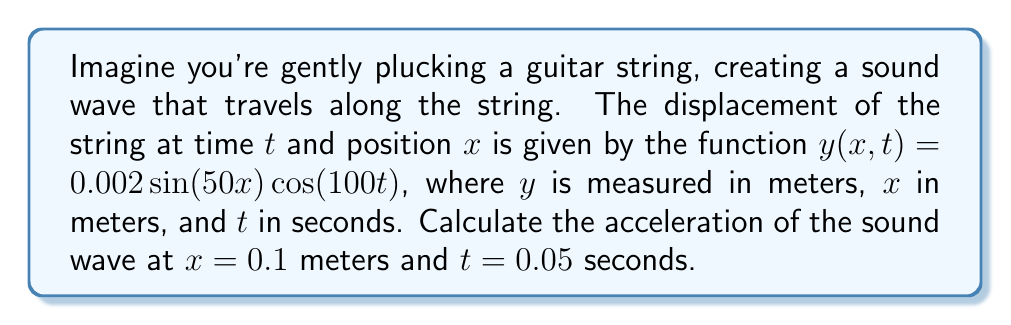Teach me how to tackle this problem. Let's approach this step-by-step:

1) The acceleration of the wave is given by the second partial derivative of $y$ with respect to time:

   $a = \frac{\partial^2y}{\partial t^2}$

2) First, let's find $\frac{\partial y}{\partial t}$:
   
   $\frac{\partial y}{\partial t} = 0.002 \sin(50x) \cdot \frac{\partial}{\partial t}[\cos(100t)]$
   $= 0.002 \sin(50x) \cdot (-100\sin(100t))$
   $= -0.2 \sin(50x) \sin(100t)$

3) Now, let's find $\frac{\partial^2 y}{\partial t^2}$:
   
   $\frac{\partial^2 y}{\partial t^2} = -0.2 \sin(50x) \cdot \frac{\partial}{\partial t}[\sin(100t)]$
   $= -0.2 \sin(50x) \cdot (100\cos(100t))$
   $= -20 \sin(50x) \cos(100t)$

4) Now we can substitute the given values: $x = 0.1$ and $t = 0.05$:

   $a = -20 \sin(50 \cdot 0.1) \cos(100 \cdot 0.05)$
   $= -20 \sin(5) \cos(5)$

5) Using a calculator (or remembering that $\sin(5) \approx 0.0872$ and $\cos(5) \approx 0.9962$):

   $a \approx -20 \cdot 0.0872 \cdot 0.9962 \approx -1.74$ m/s²

Therefore, the acceleration of the sound wave at $x = 0.1$ m and $t = 0.05$ s is approximately -1.74 m/s².
Answer: $-1.74$ m/s² 